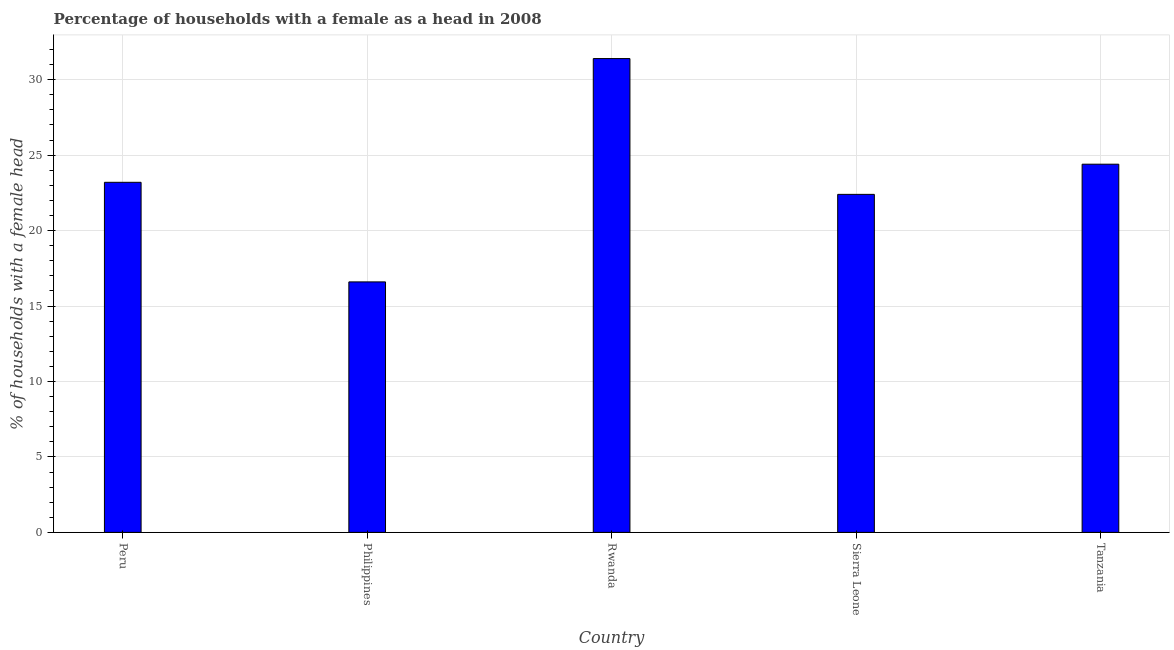Does the graph contain any zero values?
Your answer should be very brief. No. Does the graph contain grids?
Offer a very short reply. Yes. What is the title of the graph?
Keep it short and to the point. Percentage of households with a female as a head in 2008. What is the label or title of the X-axis?
Provide a short and direct response. Country. What is the label or title of the Y-axis?
Make the answer very short. % of households with a female head. What is the number of female supervised households in Sierra Leone?
Keep it short and to the point. 22.4. Across all countries, what is the maximum number of female supervised households?
Your answer should be compact. 31.4. Across all countries, what is the minimum number of female supervised households?
Your answer should be compact. 16.6. In which country was the number of female supervised households maximum?
Ensure brevity in your answer.  Rwanda. What is the sum of the number of female supervised households?
Your answer should be compact. 118. What is the difference between the number of female supervised households in Peru and Sierra Leone?
Make the answer very short. 0.8. What is the average number of female supervised households per country?
Offer a terse response. 23.6. What is the median number of female supervised households?
Provide a succinct answer. 23.2. In how many countries, is the number of female supervised households greater than 7 %?
Offer a very short reply. 5. What is the ratio of the number of female supervised households in Philippines to that in Rwanda?
Give a very brief answer. 0.53. Is the difference between the number of female supervised households in Peru and Rwanda greater than the difference between any two countries?
Make the answer very short. No. Is the sum of the number of female supervised households in Philippines and Rwanda greater than the maximum number of female supervised households across all countries?
Keep it short and to the point. Yes. What is the difference between the highest and the lowest number of female supervised households?
Make the answer very short. 14.8. In how many countries, is the number of female supervised households greater than the average number of female supervised households taken over all countries?
Provide a short and direct response. 2. How many bars are there?
Your answer should be very brief. 5. Are all the bars in the graph horizontal?
Make the answer very short. No. What is the difference between two consecutive major ticks on the Y-axis?
Your answer should be very brief. 5. What is the % of households with a female head of Peru?
Give a very brief answer. 23.2. What is the % of households with a female head in Philippines?
Your answer should be very brief. 16.6. What is the % of households with a female head in Rwanda?
Your answer should be compact. 31.4. What is the % of households with a female head in Sierra Leone?
Make the answer very short. 22.4. What is the % of households with a female head of Tanzania?
Your response must be concise. 24.4. What is the difference between the % of households with a female head in Philippines and Rwanda?
Provide a short and direct response. -14.8. What is the difference between the % of households with a female head in Philippines and Tanzania?
Keep it short and to the point. -7.8. What is the ratio of the % of households with a female head in Peru to that in Philippines?
Provide a short and direct response. 1.4. What is the ratio of the % of households with a female head in Peru to that in Rwanda?
Offer a terse response. 0.74. What is the ratio of the % of households with a female head in Peru to that in Sierra Leone?
Offer a very short reply. 1.04. What is the ratio of the % of households with a female head in Peru to that in Tanzania?
Ensure brevity in your answer.  0.95. What is the ratio of the % of households with a female head in Philippines to that in Rwanda?
Give a very brief answer. 0.53. What is the ratio of the % of households with a female head in Philippines to that in Sierra Leone?
Make the answer very short. 0.74. What is the ratio of the % of households with a female head in Philippines to that in Tanzania?
Ensure brevity in your answer.  0.68. What is the ratio of the % of households with a female head in Rwanda to that in Sierra Leone?
Your answer should be compact. 1.4. What is the ratio of the % of households with a female head in Rwanda to that in Tanzania?
Your answer should be very brief. 1.29. What is the ratio of the % of households with a female head in Sierra Leone to that in Tanzania?
Your answer should be compact. 0.92. 